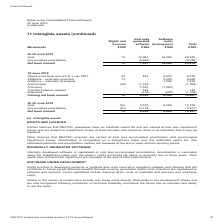According to Nextdc's financial document, How was internally developed software capitalised? at cost less accumulated amortisation.. The document states: "Internally developed software is capitalised at cost less accumulated amortisation. Amortisation is calculated using the straight-line basis over the ..." Also, How much was the closing net book amount for software under development in 2019? According to the financial document, 16,284 (in thousands). The relevant text states: "At 30 June 2019 Cost 13 12,961 16,284 29,258 Accumulated amortisation - (5,580) - (5,580) Net book amount 13 7,381 16,284 23,678..." Also, What was the total cost for 2019? Based on the financial document, the answer is 29,259 (in thousands). Also, can you calculate: What was the percentage change in cost of software under development between 2018 and 2019? To answer this question, I need to perform calculations using the financial data. The calculation is: (16,284 - 6,509) / 6,509 , which equals 150.18 (percentage). This is based on the information: "8) (490) (1,108) Closing net book amount 13 6,385 6,509 12,907 At 30 June 2019 Cost 13 12,961 16,284 29,258 Accumulated amortisation - (5,580) - (5,580) Net book amount 13 7,381 16,284 23,678..." The key data points involved are: 16,284, 6,509. Additionally, Which year have greater total accumulated amortisation?  According to the financial document, 2019. The relevant text states: "At 30 June 2019 Cost 13 12,961 16,284 29,258 Accumulated amortisation - (5,580) - (5,580) Net book amount 13 7,381..." Also, can you calculate: What was the difference between total opening and closing net book account in 2018? Based on the calculation: 12,907 - 8,538 , the result is 4369 (in thousands). This is based on the information: "0) (1,108) Closing net book amount 13 6,385 6,509 12,907 ening net book amount at 1 July 2017 43 442 8,053 8,538 Additions – externally acquired 13 - 5,253 5,266 Additions – internally developed - - 1..." The key data points involved are: 12,907, 8,538. 